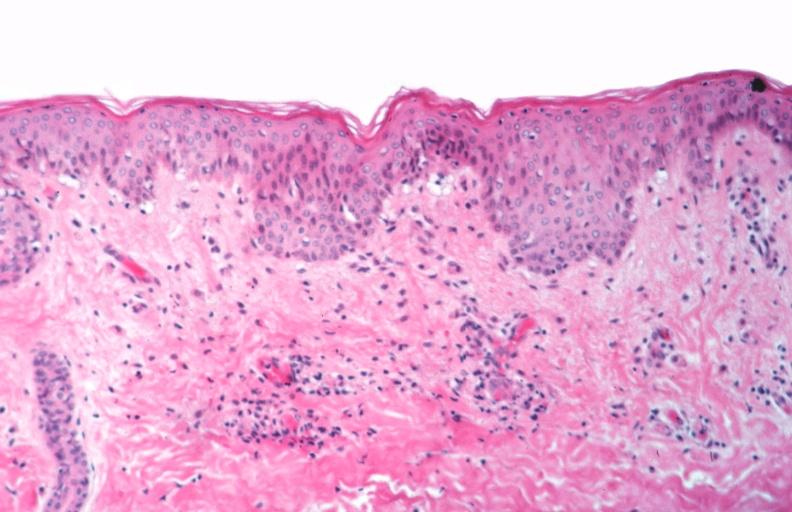does this image show skin?
Answer the question using a single word or phrase. Yes 